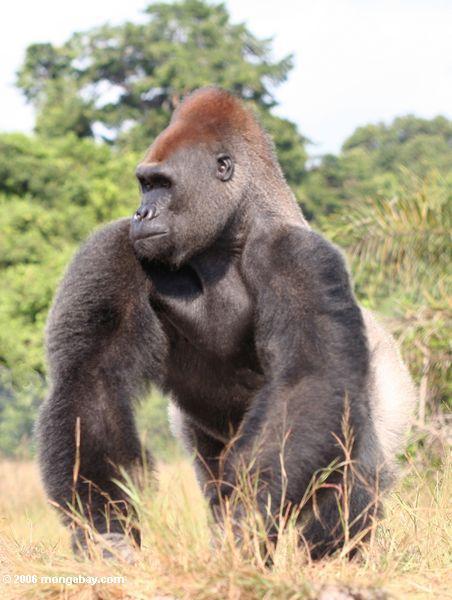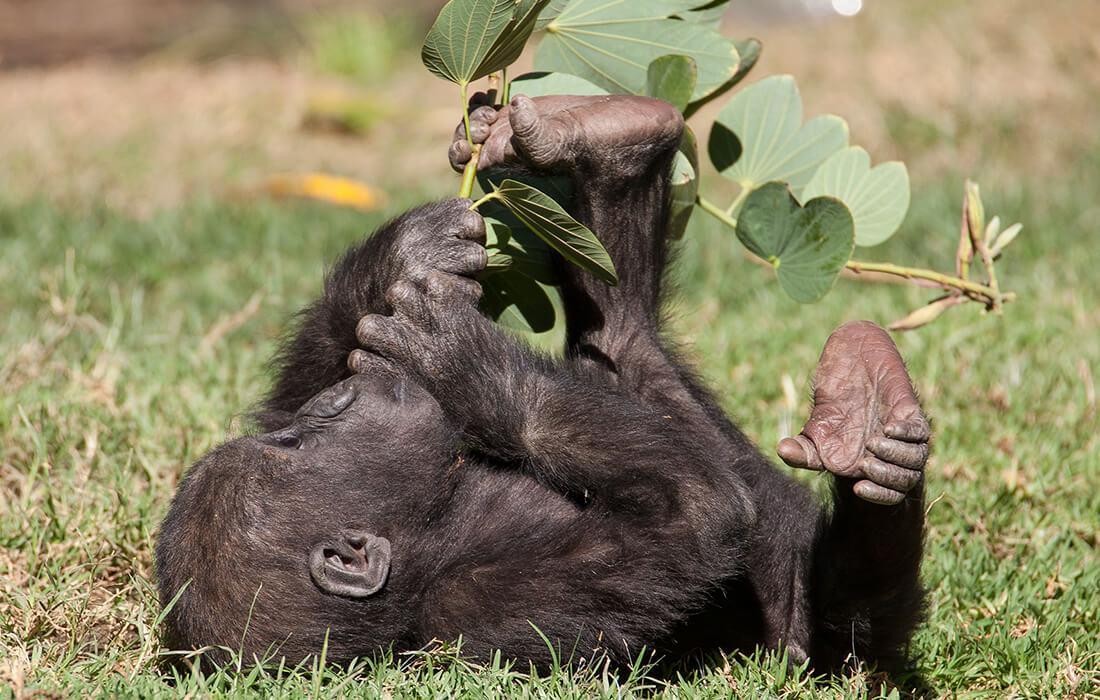The first image is the image on the left, the second image is the image on the right. For the images displayed, is the sentence "A mother gorilla is holding her infant on one arm" factually correct? Answer yes or no. No. The first image is the image on the left, the second image is the image on the right. For the images shown, is this caption "The left image shows a baby gorilla clinging to the arm of an adult gorilla, and the right image includes a hand touching a foot." true? Answer yes or no. No. 